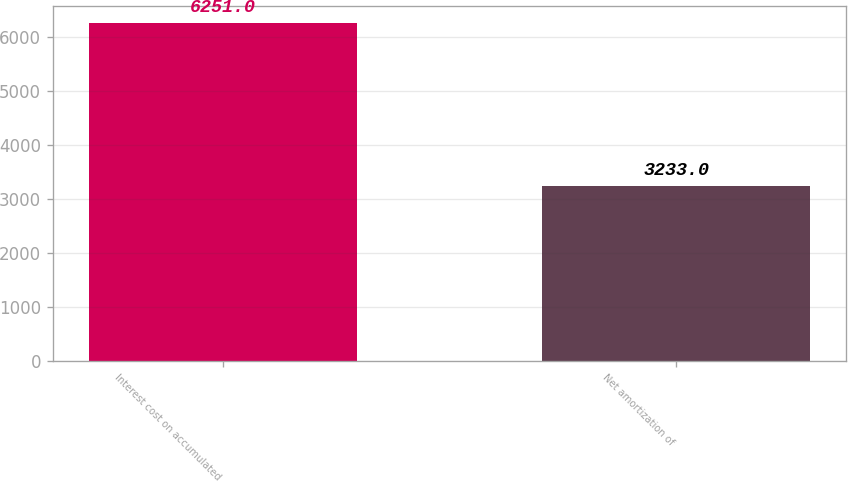<chart> <loc_0><loc_0><loc_500><loc_500><bar_chart><fcel>Interest cost on accumulated<fcel>Net amortization of<nl><fcel>6251<fcel>3233<nl></chart> 